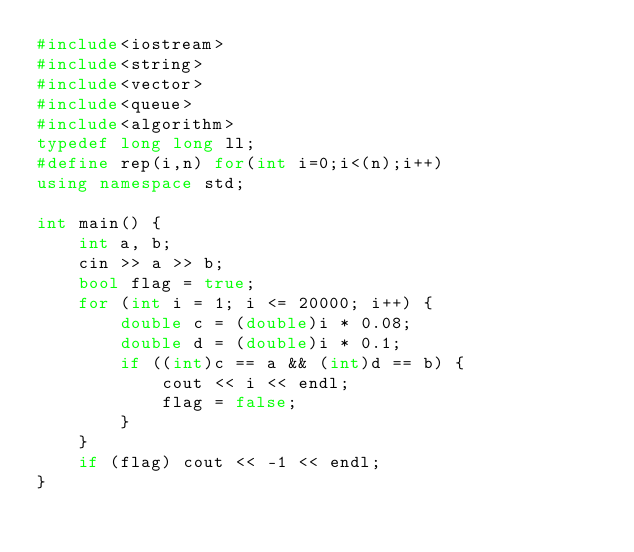Convert code to text. <code><loc_0><loc_0><loc_500><loc_500><_C++_>#include<iostream>
#include<string>
#include<vector>
#include<queue>
#include<algorithm>
typedef long long ll;
#define rep(i,n) for(int i=0;i<(n);i++)
using namespace std;

int main() {
	int a, b;
	cin >> a >> b;
	bool flag = true;
	for (int i = 1; i <= 20000; i++) {
		double c = (double)i * 0.08;
		double d = (double)i * 0.1;
		if ((int)c == a && (int)d == b) {
			cout << i << endl;
			flag = false;
		}
	}
	if (flag) cout << -1 << endl;
}
</code> 